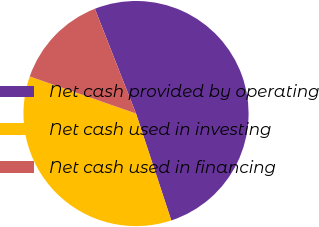Convert chart to OTSL. <chart><loc_0><loc_0><loc_500><loc_500><pie_chart><fcel>Net cash provided by operating<fcel>Net cash used in investing<fcel>Net cash used in financing<nl><fcel>50.88%<fcel>35.42%<fcel>13.7%<nl></chart> 